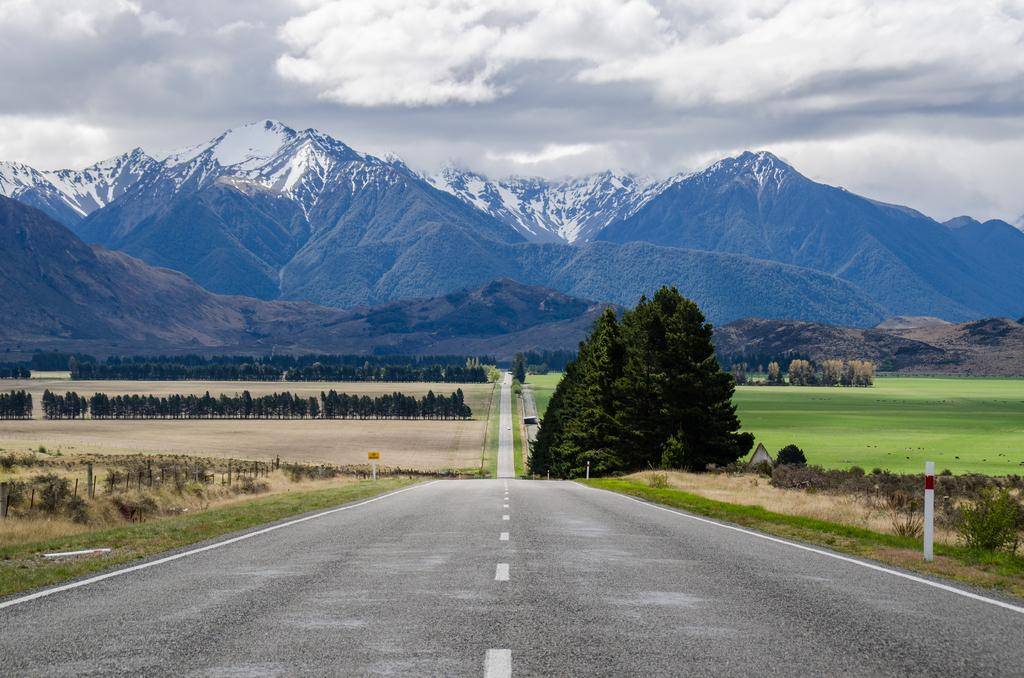What is the main feature in the center of the image? There is a road in the center of the image. What can be seen on the left side of the image? There are trees and grass on the left side of the image. What is visible in the background of the image? There are mountains in the background of the image. What can be seen in the sky in the image? There are clouds visible in the sky. What type of furniture is visible in the image? There is no furniture present in the image. Can you tell me how many mothers are in the image? There are no mothers depicted in the image. 